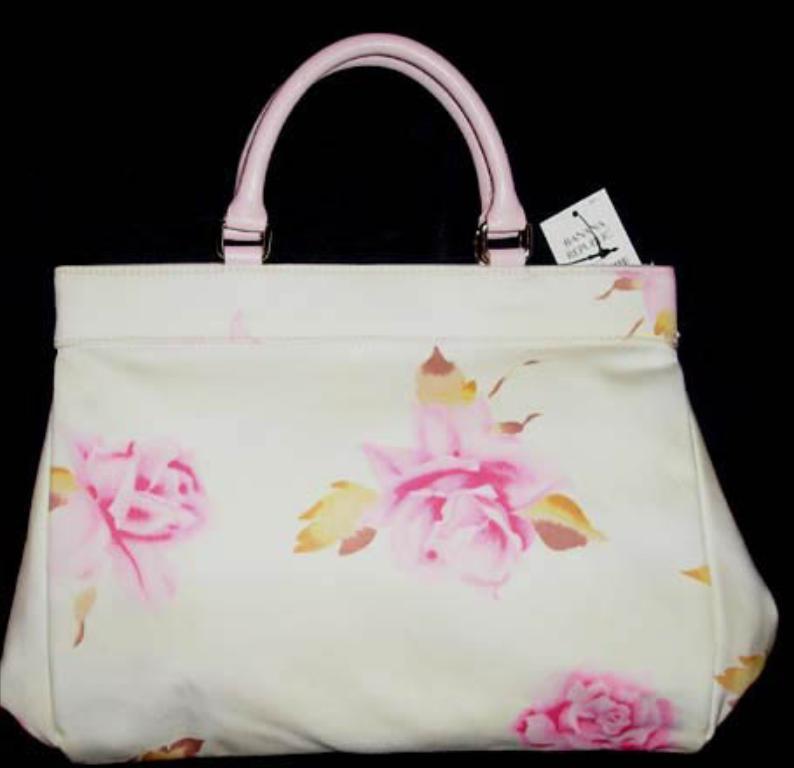How would you summarize this image in a sentence or two? In this image their is a handbag to which there is a tag attached. 